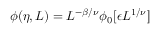<formula> <loc_0><loc_0><loc_500><loc_500>\phi ( \eta , L ) = L ^ { - \beta / \nu } \phi _ { 0 } [ \epsilon L ^ { 1 / \nu } ]</formula> 